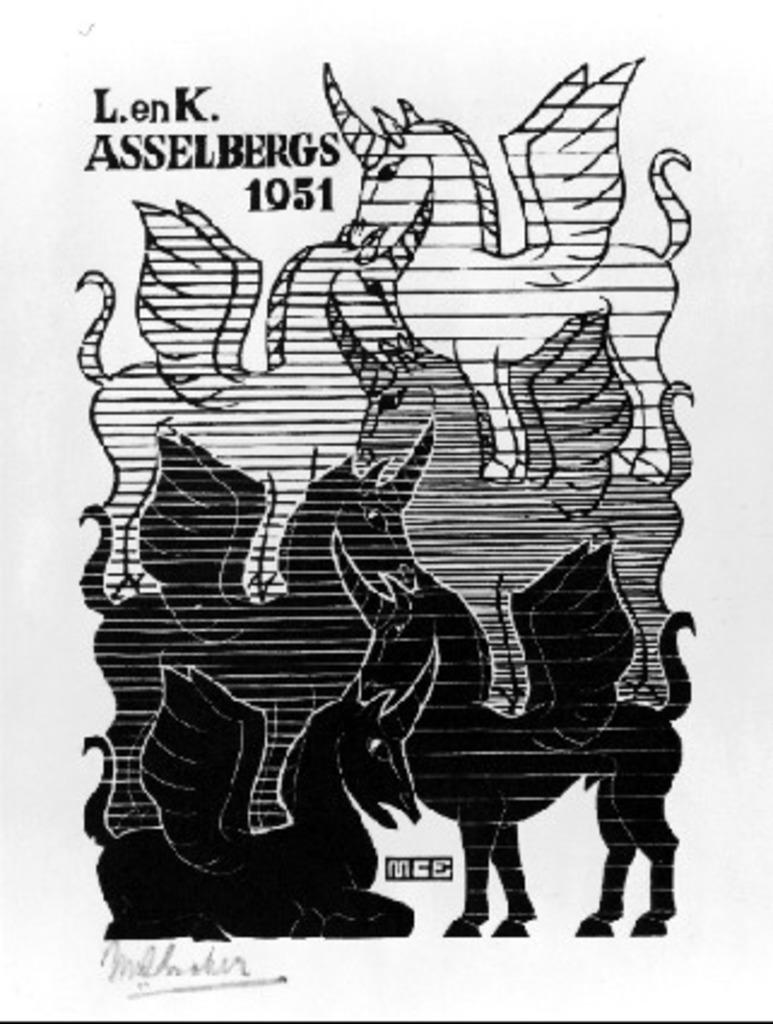What type of art is depicted in the image? There is a pencil art of an animal in the image. What other elements can be seen in the image besides the pencil art? There is text at the top and bottom of the image. What is the title of the expert's book mentioned in the image? There is no expert or book mentioned in the image; it only contains a pencil art of an animal and text at the top and bottom. 